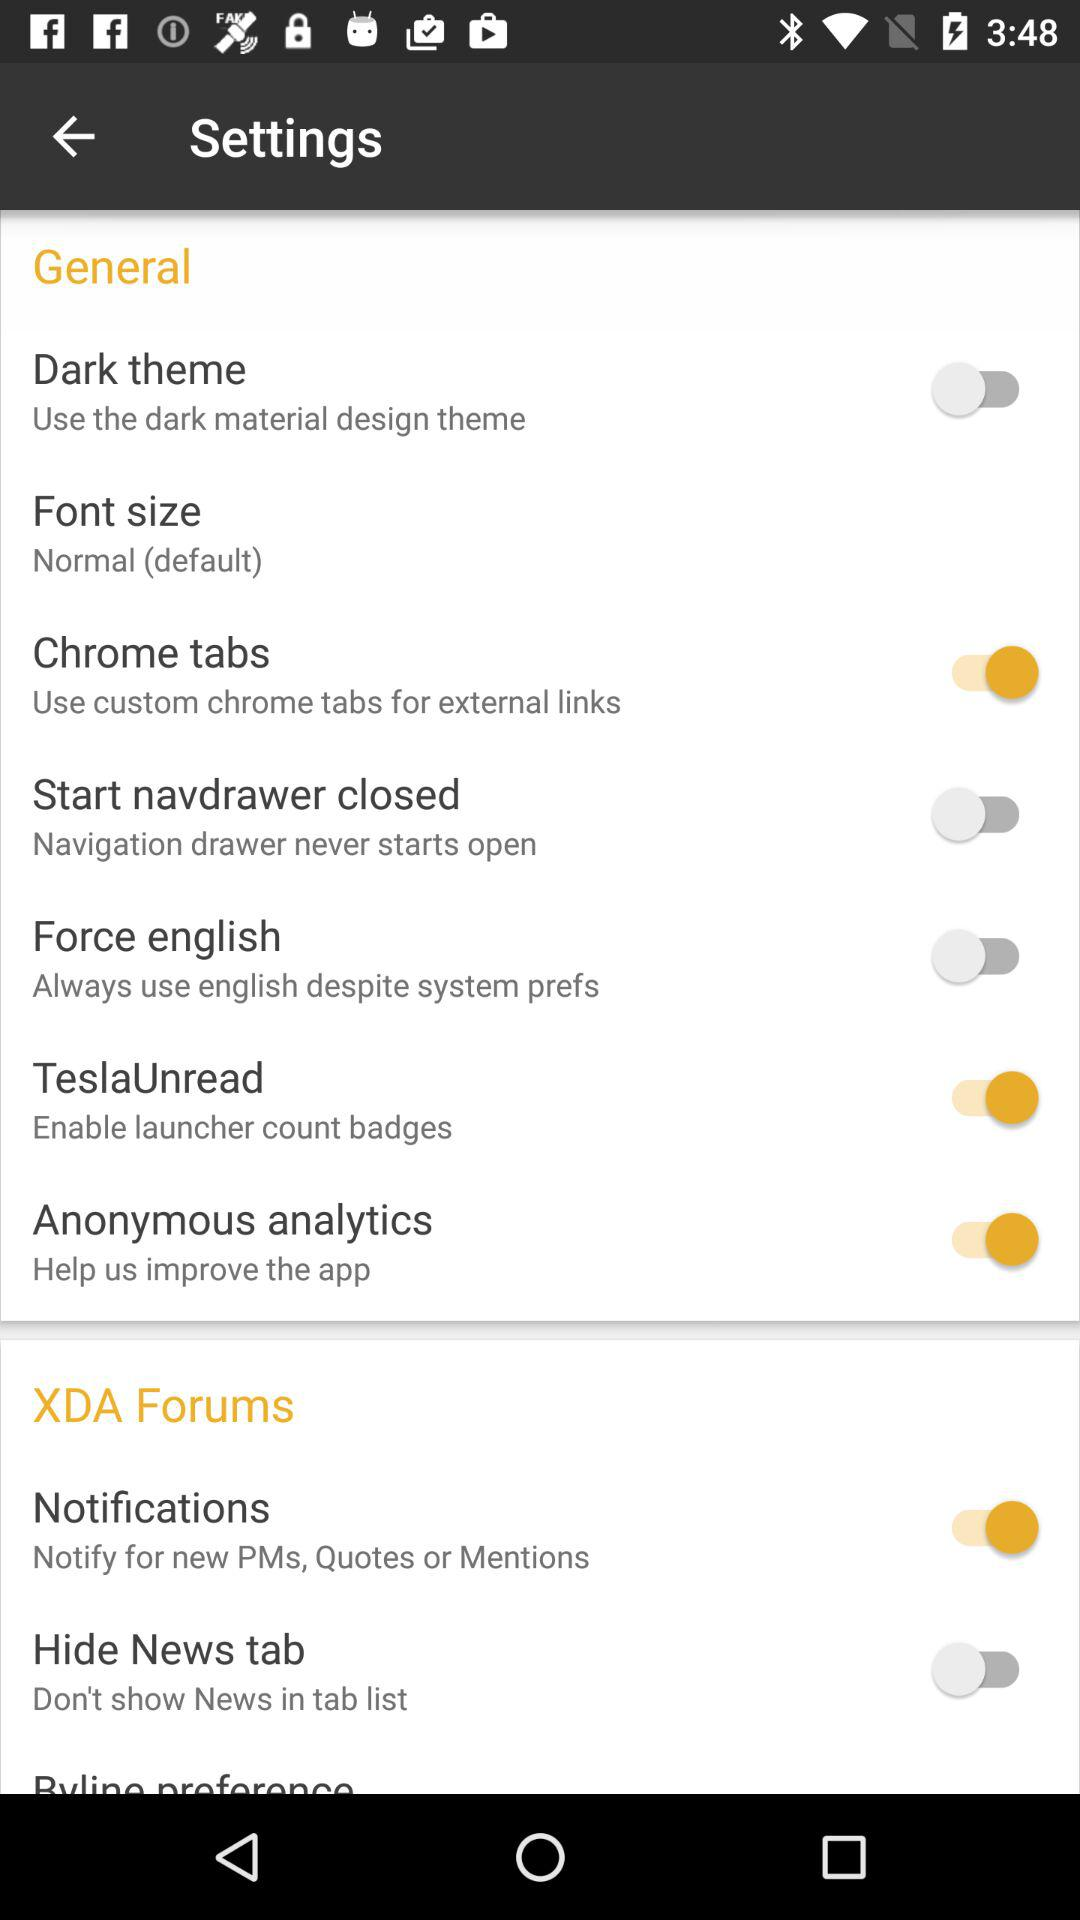What's the font size? The font size is "Normal (default)". 